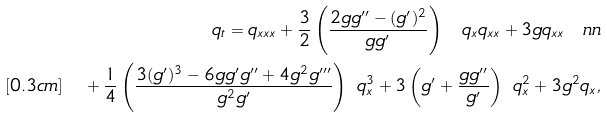<formula> <loc_0><loc_0><loc_500><loc_500>q _ { t } = q _ { x x x } + \frac { 3 } { 2 } \left ( \frac { 2 g g ^ { \prime \prime } - ( g ^ { \prime } ) ^ { 2 } } { g g ^ { \prime } } \right ) \ q _ { x } q _ { x x } + 3 g q _ { x x } \ n n \\ [ 0 . 3 c m ] \quad + \frac { 1 } { 4 } \left ( \frac { 3 ( g ^ { \prime } ) ^ { 3 } - 6 g g ^ { \prime } g ^ { \prime \prime } + 4 g ^ { 2 } g ^ { \prime \prime \prime } } { g ^ { 2 } g ^ { \prime } } \right ) \ q _ { x } ^ { 3 } + 3 \left ( g ^ { \prime } + \frac { g g ^ { \prime \prime } } { g ^ { \prime } } \right ) \ q _ { x } ^ { 2 } + 3 g ^ { 2 } q _ { x } ,</formula> 